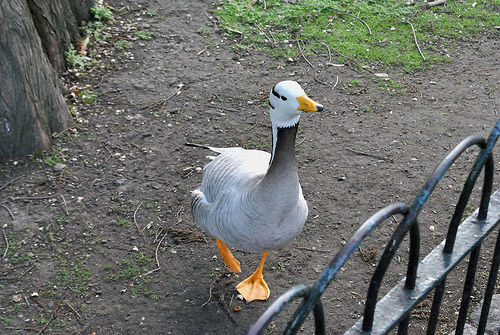<image>
Can you confirm if the duck is next to the fence? Yes. The duck is positioned adjacent to the fence, located nearby in the same general area. 